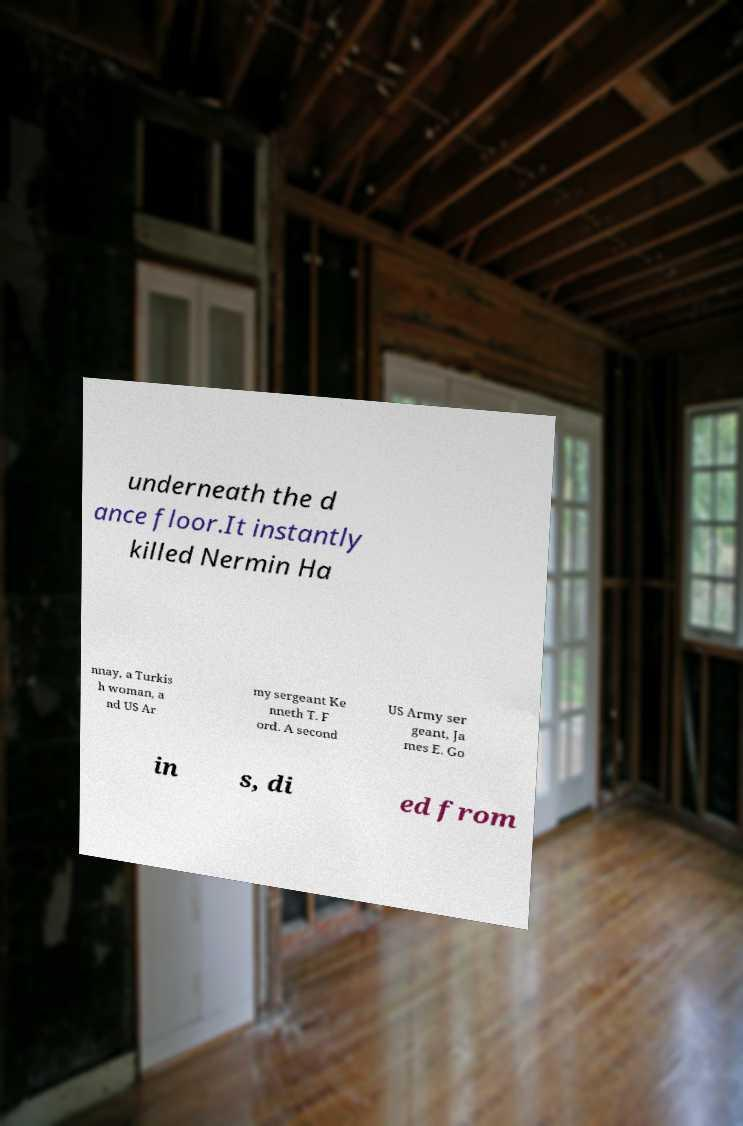Could you extract and type out the text from this image? underneath the d ance floor.It instantly killed Nermin Ha nnay, a Turkis h woman, a nd US Ar my sergeant Ke nneth T. F ord. A second US Army ser geant, Ja mes E. Go in s, di ed from 